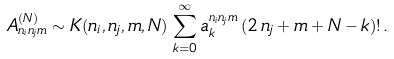<formula> <loc_0><loc_0><loc_500><loc_500>A ^ { ( N ) } _ { n _ { i } n _ { j } m } \sim K ( n _ { i } , n _ { j } , m , N ) \, \sum _ { k = 0 } ^ { \infty } a ^ { n _ { i } n _ { j } m } _ { k } \, ( 2 \, n _ { j } + m + N - k ) ! \, .</formula> 